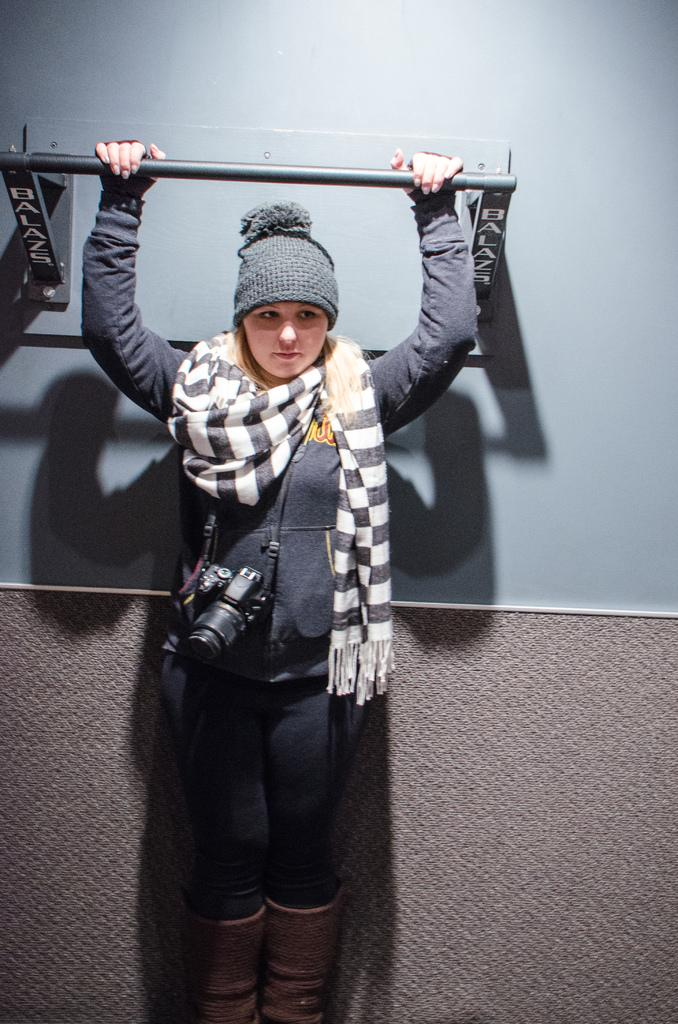Who is the main subject in the image? There is a woman in the image. What is the woman wearing in the image? The woman is wearing a camera and a scarf in the image. What is the woman holding in the image? The woman is holding a rod with her hands in the image. What type of tomatoes can be seen growing in the background of the image? There are no tomatoes present in the image; it features a woman wearing a camera and a scarf, and holding a rod. 